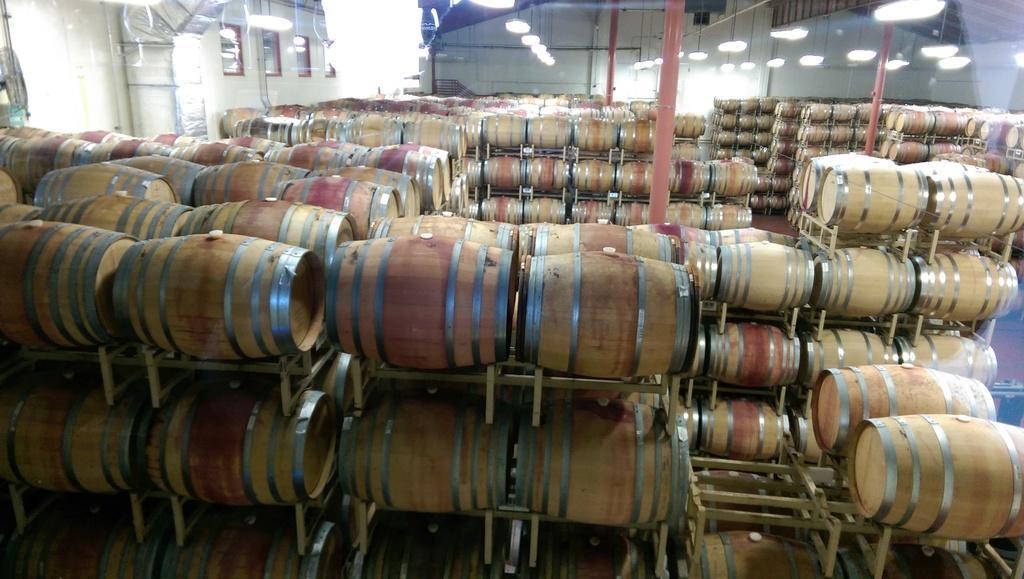How would you summarize this image in a sentence or two? In the picture we can see a shed room in that we can see number of drums are placed on the stands and in the background, we can see some poles and to the ceiling we can see some lights. 